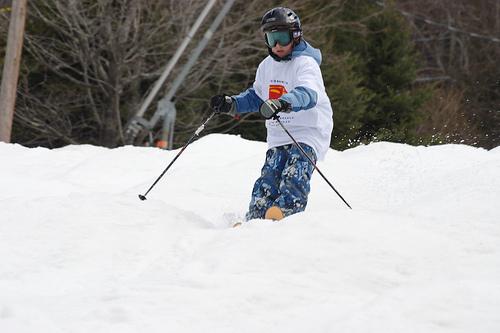Is that kid  skiing or just standing still?
Be succinct. Skiing. What does this boy have on his face?
Be succinct. Goggles. Why is the kid dressing this way?
Quick response, please. Cold. 